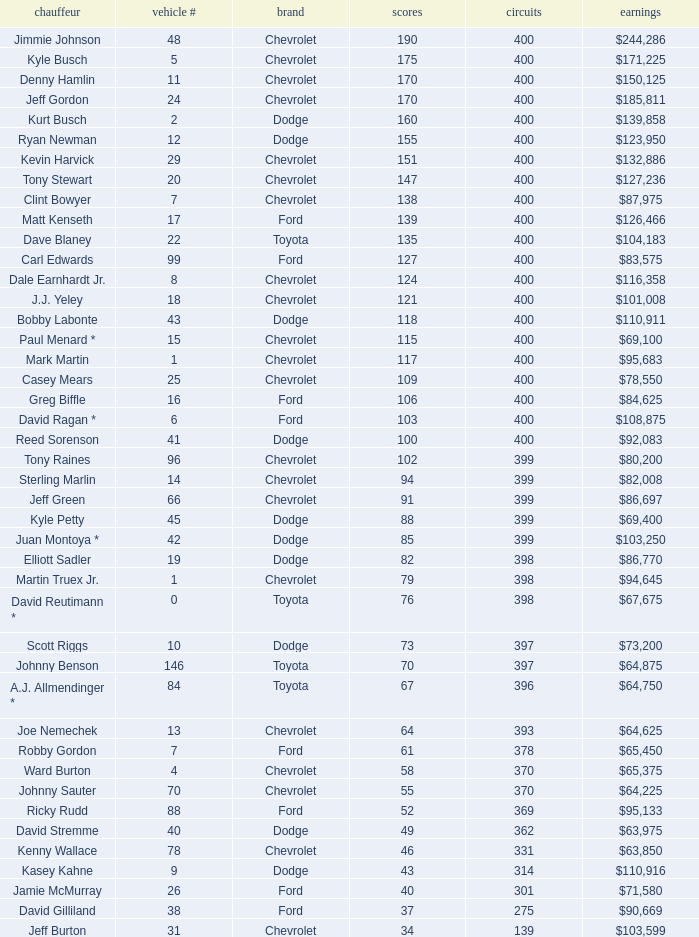What is the car number that has less than 369 laps for a Dodge with more than 49 points? None. 